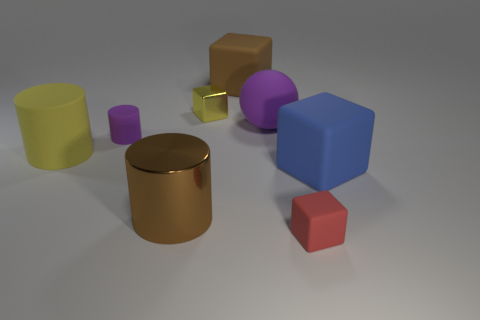There is a blue rubber object that is the same shape as the brown matte object; what is its size?
Keep it short and to the point. Large. There is a small metallic cube; how many small purple matte cylinders are behind it?
Keep it short and to the point. 0. What color is the small rubber thing behind the metallic thing that is in front of the metallic block?
Make the answer very short. Purple. Are there any other things that are the same shape as the big yellow object?
Your response must be concise. Yes. Is the number of brown rubber blocks that are left of the red rubber cube the same as the number of big brown rubber blocks in front of the purple cylinder?
Your response must be concise. No. What number of balls are either small objects or large yellow rubber objects?
Give a very brief answer. 0. How many other objects are there of the same material as the red cube?
Give a very brief answer. 5. There is a brown thing left of the brown block; what is its shape?
Your answer should be very brief. Cylinder. There is a purple object on the right side of the tiny matte thing that is behind the big blue object; what is its material?
Ensure brevity in your answer.  Rubber. Is the number of small cylinders that are on the right side of the rubber ball greater than the number of matte cubes?
Keep it short and to the point. No. 